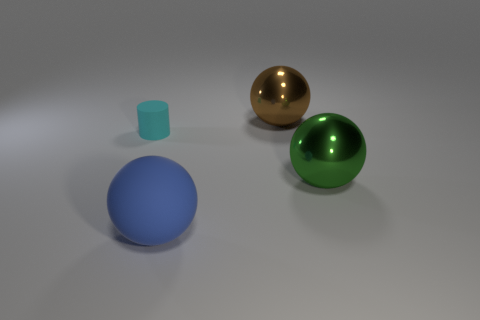Add 2 spheres. How many objects exist? 6 Subtract all cylinders. How many objects are left? 3 Subtract all tiny rubber cylinders. Subtract all large rubber blocks. How many objects are left? 3 Add 3 small rubber objects. How many small rubber objects are left? 4 Add 3 small cyan matte objects. How many small cyan matte objects exist? 4 Subtract 0 brown blocks. How many objects are left? 4 